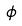<formula> <loc_0><loc_0><loc_500><loc_500>\hat { \phi }</formula> 